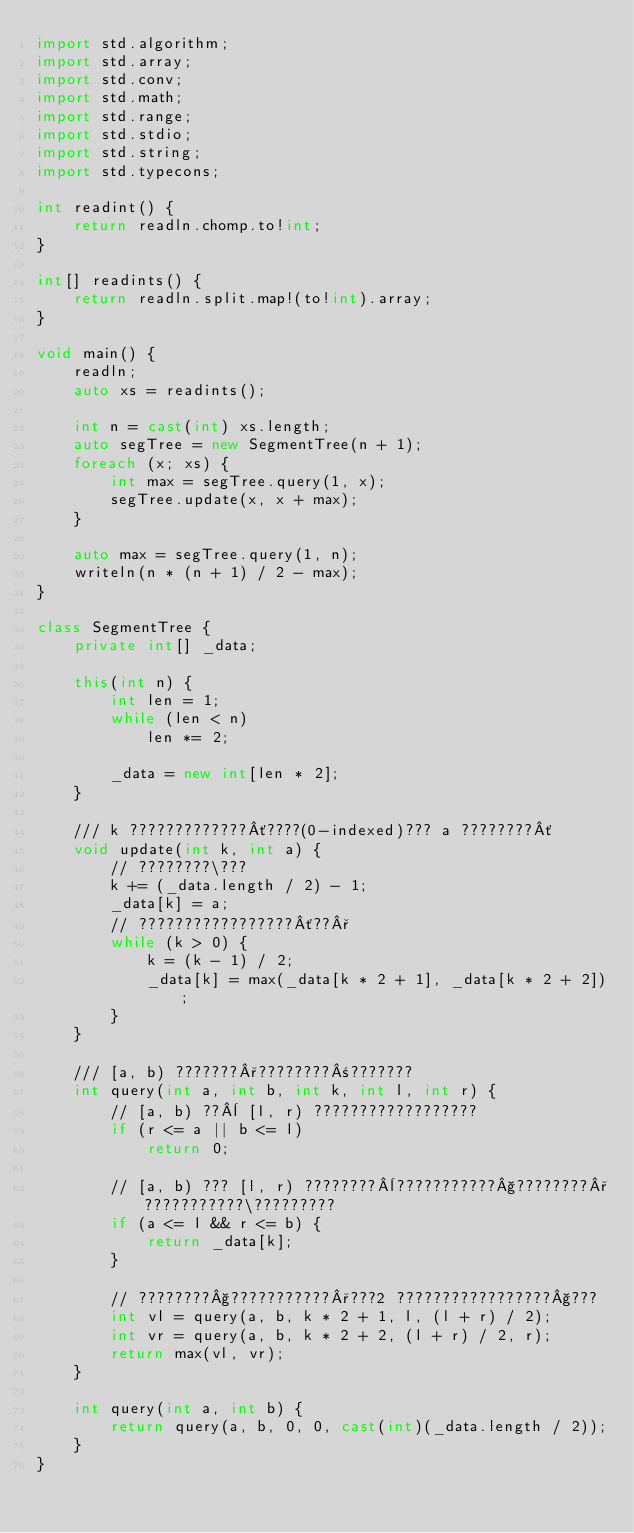Convert code to text. <code><loc_0><loc_0><loc_500><loc_500><_D_>import std.algorithm;
import std.array;
import std.conv;
import std.math;
import std.range;
import std.stdio;
import std.string;
import std.typecons;

int readint() {
    return readln.chomp.to!int;
}

int[] readints() {
    return readln.split.map!(to!int).array;
}

void main() {
    readln;
    auto xs = readints();

    int n = cast(int) xs.length;
    auto segTree = new SegmentTree(n + 1);
    foreach (x; xs) {
        int max = segTree.query(1, x);
        segTree.update(x, x + max);
    }

    auto max = segTree.query(1, n);
    writeln(n * (n + 1) / 2 - max);
}

class SegmentTree {
    private int[] _data;

    this(int n) {
        int len = 1;
        while (len < n)
            len *= 2;

        _data = new int[len * 2];
    }

    /// k ?????????????´????(0-indexed)??? a ????????´
    void update(int k, int a) {
        // ????????\???
        k += (_data.length / 2) - 1;
        _data[k] = a;
        // ?????????????????´??°
        while (k > 0) {
            k = (k - 1) / 2;
            _data[k] = max(_data[k * 2 + 1], _data[k * 2 + 2]);
        }
    }

    /// [a, b) ???????°????????±???????
    int query(int a, int b, int k, int l, int r) {
        // [a, b) ??¨ [l, r) ??????????????????
        if (r <= a || b <= l)
            return 0;

        // [a, b) ??? [l, r) ????????¨???????????§????????°???????????\?????????
        if (a <= l && r <= b) {
            return _data[k];
        }

        // ????????§???????????°???2 ?????????????????§???
        int vl = query(a, b, k * 2 + 1, l, (l + r) / 2);
        int vr = query(a, b, k * 2 + 2, (l + r) / 2, r);
        return max(vl, vr);
    }

    int query(int a, int b) {
        return query(a, b, 0, 0, cast(int)(_data.length / 2));
    }
}</code> 